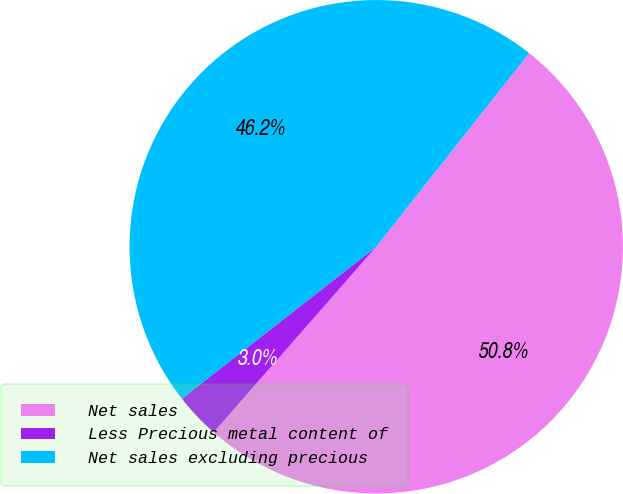Convert chart to OTSL. <chart><loc_0><loc_0><loc_500><loc_500><pie_chart><fcel>Net sales<fcel>Less Precious metal content of<fcel>Net sales excluding precious<nl><fcel>50.82%<fcel>2.99%<fcel>46.2%<nl></chart> 